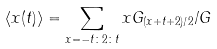<formula> <loc_0><loc_0><loc_500><loc_500>\langle { x ( t ) } \rangle = \sum _ { x = - t \colon 2 \colon t } x G _ { ( x + t + 2 ) / 2 } / G</formula> 